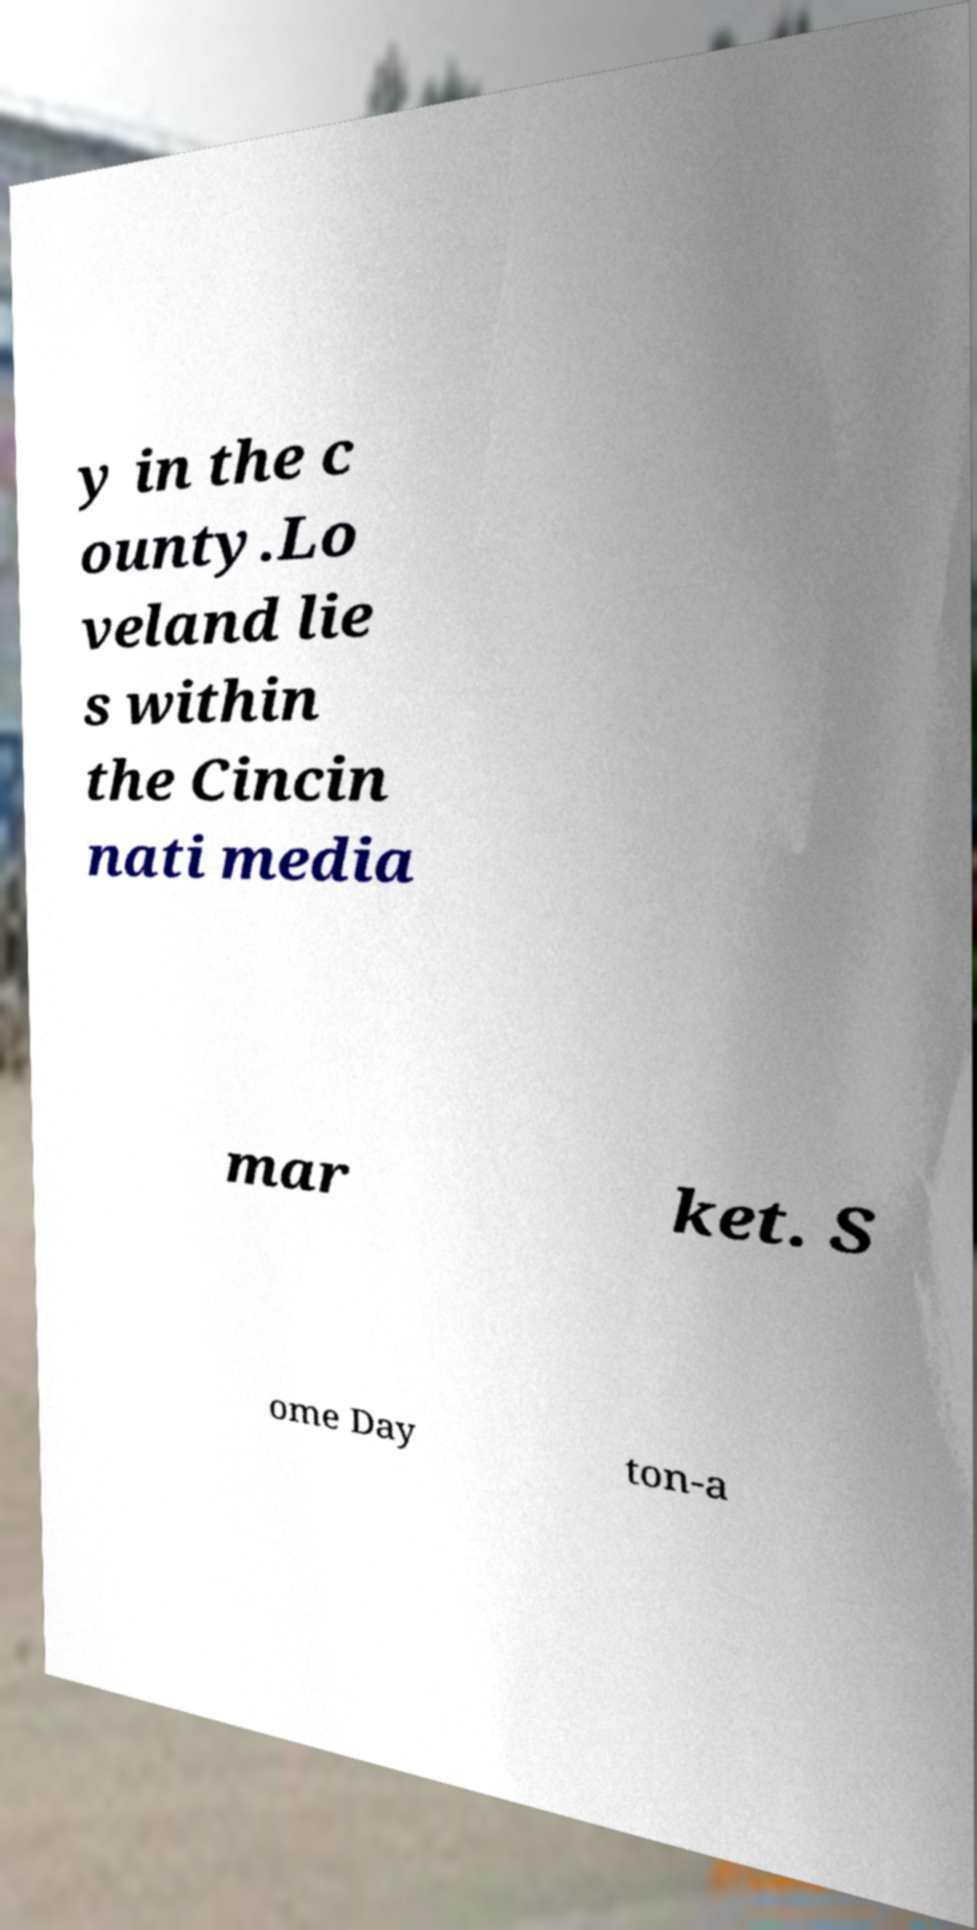I need the written content from this picture converted into text. Can you do that? y in the c ounty.Lo veland lie s within the Cincin nati media mar ket. S ome Day ton-a 